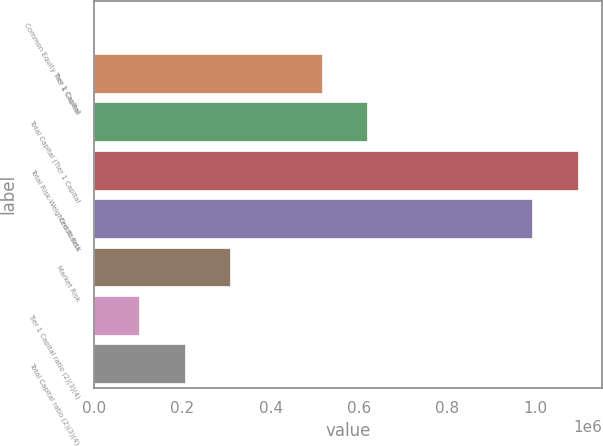<chart> <loc_0><loc_0><loc_500><loc_500><bar_chart><fcel>Common Equity Tier 1 Capital<fcel>Tier 1 Capital<fcel>Total Capital (Tier 1 Capital<fcel>Total Risk-Weighted Assets<fcel>Credit Risk<fcel>Market Risk<fcel>Tier 1 Capital ratio (2)(3)(4)<fcel>Total Capital ratio (2)(3)(4)<nl><fcel>12.54<fcel>515263<fcel>618313<fcel>1.09505e+06<fcel>991999<fcel>309163<fcel>103063<fcel>206113<nl></chart> 